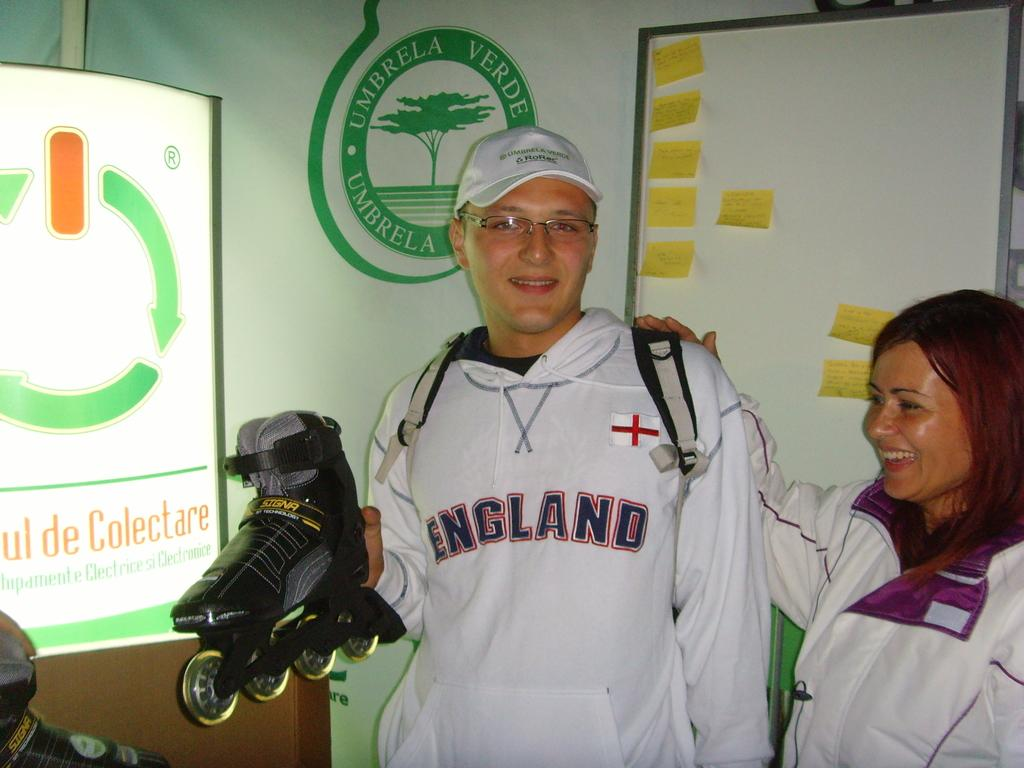<image>
Describe the image concisely. a person wearing a sweatshirt that says England on it 